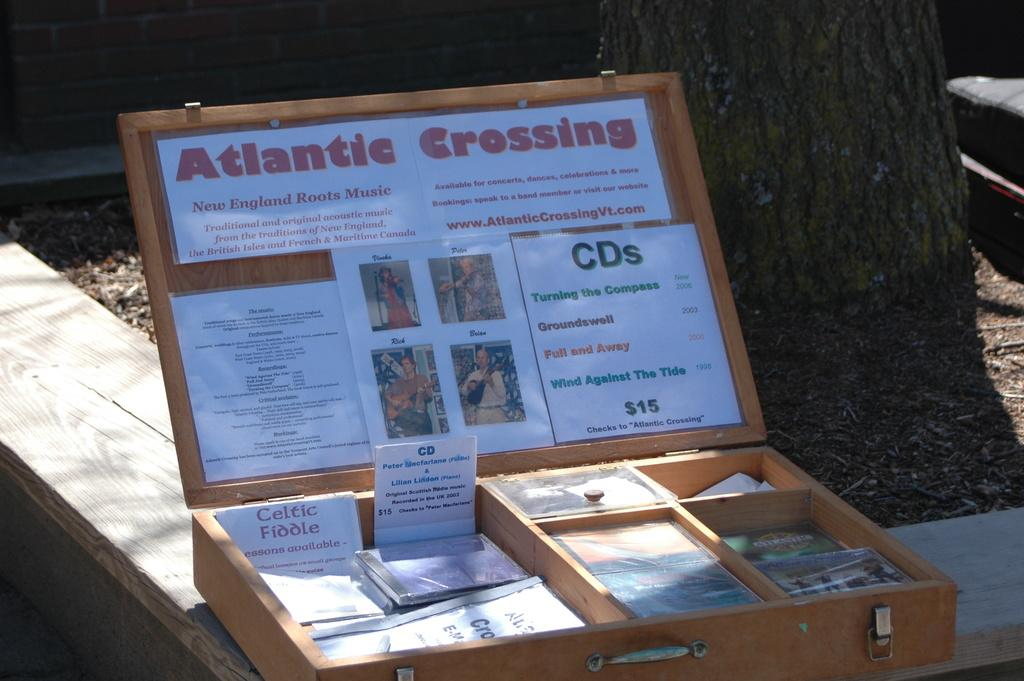<image>
Write a terse but informative summary of the picture. A box filled will items to sell, CD's from ATlantic Crossing. 